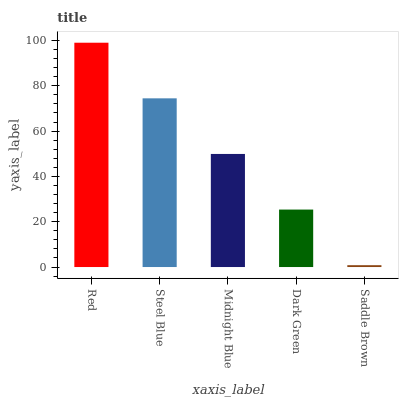Is Saddle Brown the minimum?
Answer yes or no. Yes. Is Red the maximum?
Answer yes or no. Yes. Is Steel Blue the minimum?
Answer yes or no. No. Is Steel Blue the maximum?
Answer yes or no. No. Is Red greater than Steel Blue?
Answer yes or no. Yes. Is Steel Blue less than Red?
Answer yes or no. Yes. Is Steel Blue greater than Red?
Answer yes or no. No. Is Red less than Steel Blue?
Answer yes or no. No. Is Midnight Blue the high median?
Answer yes or no. Yes. Is Midnight Blue the low median?
Answer yes or no. Yes. Is Steel Blue the high median?
Answer yes or no. No. Is Saddle Brown the low median?
Answer yes or no. No. 